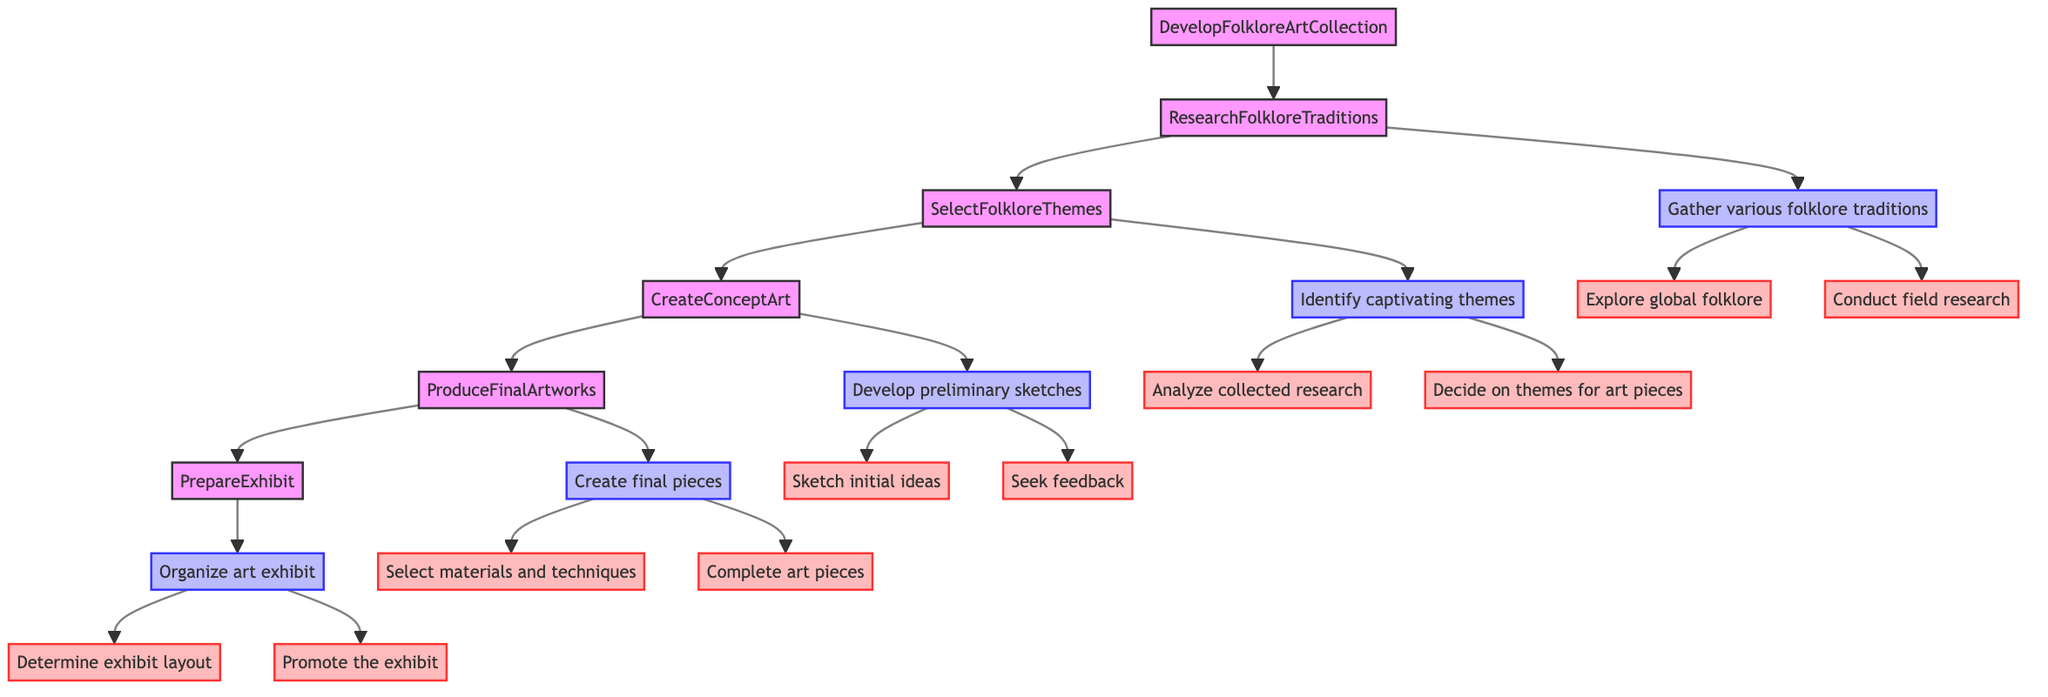What is the first step in developing a folklore art collection? The first step in the flowchart is "ResearchFolkloreTraditions," which is the starting point for the process of developing the collection.
Answer: ResearchFolkloreTraditions How many main actions are there under the "ResearchFolkloreTraditions" step? Under the "ResearchFolkloreTraditions" step, there are two main actions: "Explore global folklore" and "Conduct field research."
Answer: 2 Which action follows "SelectFolkloreThemes"? The action that follows "SelectFolkloreThemes" in the flowchart is "CreateConceptArt," indicating the progression from theme selection to the creation of art concepts.
Answer: CreateConceptArt What method is used to gather feedback in the "CreateConceptArt" step? In the "CreateConceptArt" step, one method to gather feedback is to share concept art with peer artists and mentors for critique.
Answer: Share concept art How many actions do you need to take to "PrepareExhibit"? In the "PrepareExhibit" step, there are two actions to be taken: "Determine exhibit layout" and "Promote the exhibit." Thus, you need to undertake two actions.
Answer: 2 What action follows "Analyze collected research"? The action that follows "Analyze collected research" is "Decide on themes for art pieces," which indicates the next step in identifying themes after analyzing research insights.
Answer: Decide on themes for art pieces What is the last step in the process of developing a folklore art collection? The last step in the process as identified in the diagram is "PrepareExhibit," indicating that after producing the final artworks, the next task is organizing the exhibit.
Answer: PrepareExhibit Which medium is not mentioned for creating final pieces? The diagram includes media like oil paint, watercolor, and digital art in the "Select materials and techniques" method, but it does not mention acrylic.
Answer: Acrylic How many different themes are provided as examples under "Decide on themes for art pieces"? Three themes are given as examples under "Decide on themes for art pieces": "Slavic mythology's Baba Yaga," "Japanese Yōkai spirits," and "Norse mythological creatures," thus totaling three themes.
Answer: 3 